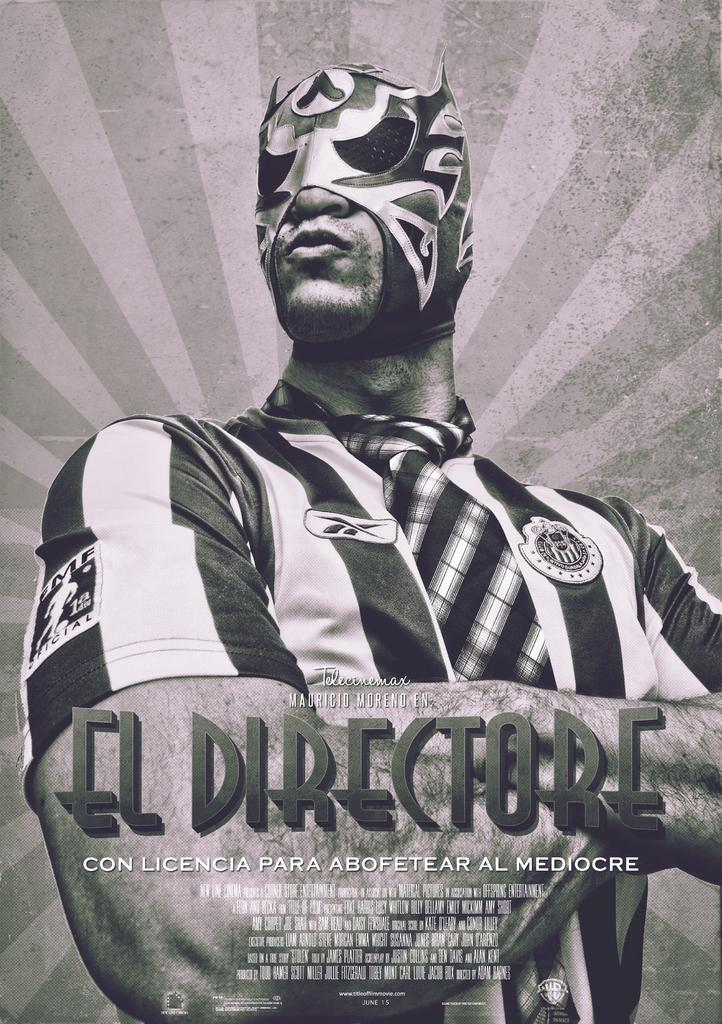What is depicted on the poster in the image? The poster features a man. What is the man wearing in the image? The man is wearing a mask. What type of expansion is shown in the image? There is no expansion present in the image; it features a poster with a man wearing a mask. Can you see a sink in the image? There is no sink present in the image. 